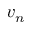Convert formula to latex. <formula><loc_0><loc_0><loc_500><loc_500>v _ { n }</formula> 